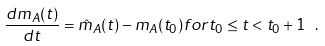<formula> <loc_0><loc_0><loc_500><loc_500>\frac { d m _ { A } ( t ) } { d t } = \hat { m } _ { A } ( t ) - m _ { A } ( t _ { 0 } ) f o r t _ { 0 } \leq t < t _ { 0 } + 1 \ .</formula> 